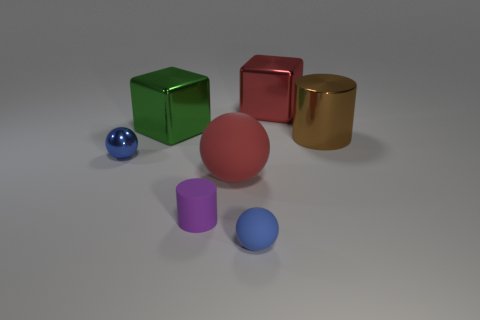There is a shiny object that is the same color as the tiny rubber ball; what is its size?
Your answer should be compact. Small. How many other spheres are the same color as the tiny metal ball?
Offer a terse response. 1. There is a green object left of the large cube that is to the right of the rubber ball that is in front of the purple rubber object; how big is it?
Offer a terse response. Large. Do the tiny blue matte object and the shiny object behind the green thing have the same shape?
Give a very brief answer. No. What is the brown cylinder made of?
Give a very brief answer. Metal. How many matte things are either balls or large brown cylinders?
Keep it short and to the point. 2. Are there fewer green blocks that are in front of the green cube than big shiny cylinders behind the brown shiny cylinder?
Offer a terse response. No. There is a small metal thing in front of the shiny thing behind the big green metal cube; are there any balls that are on the right side of it?
Offer a very short reply. Yes. There is a small sphere that is the same color as the tiny shiny thing; what is it made of?
Give a very brief answer. Rubber. There is a red object that is behind the blue metal object; is it the same shape as the big shiny object to the left of the red block?
Provide a succinct answer. Yes. 